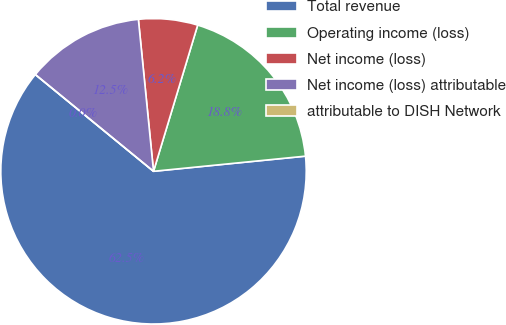Convert chart. <chart><loc_0><loc_0><loc_500><loc_500><pie_chart><fcel>Total revenue<fcel>Operating income (loss)<fcel>Net income (loss)<fcel>Net income (loss) attributable<fcel>attributable to DISH Network<nl><fcel>62.5%<fcel>18.75%<fcel>6.25%<fcel>12.5%<fcel>0.0%<nl></chart> 